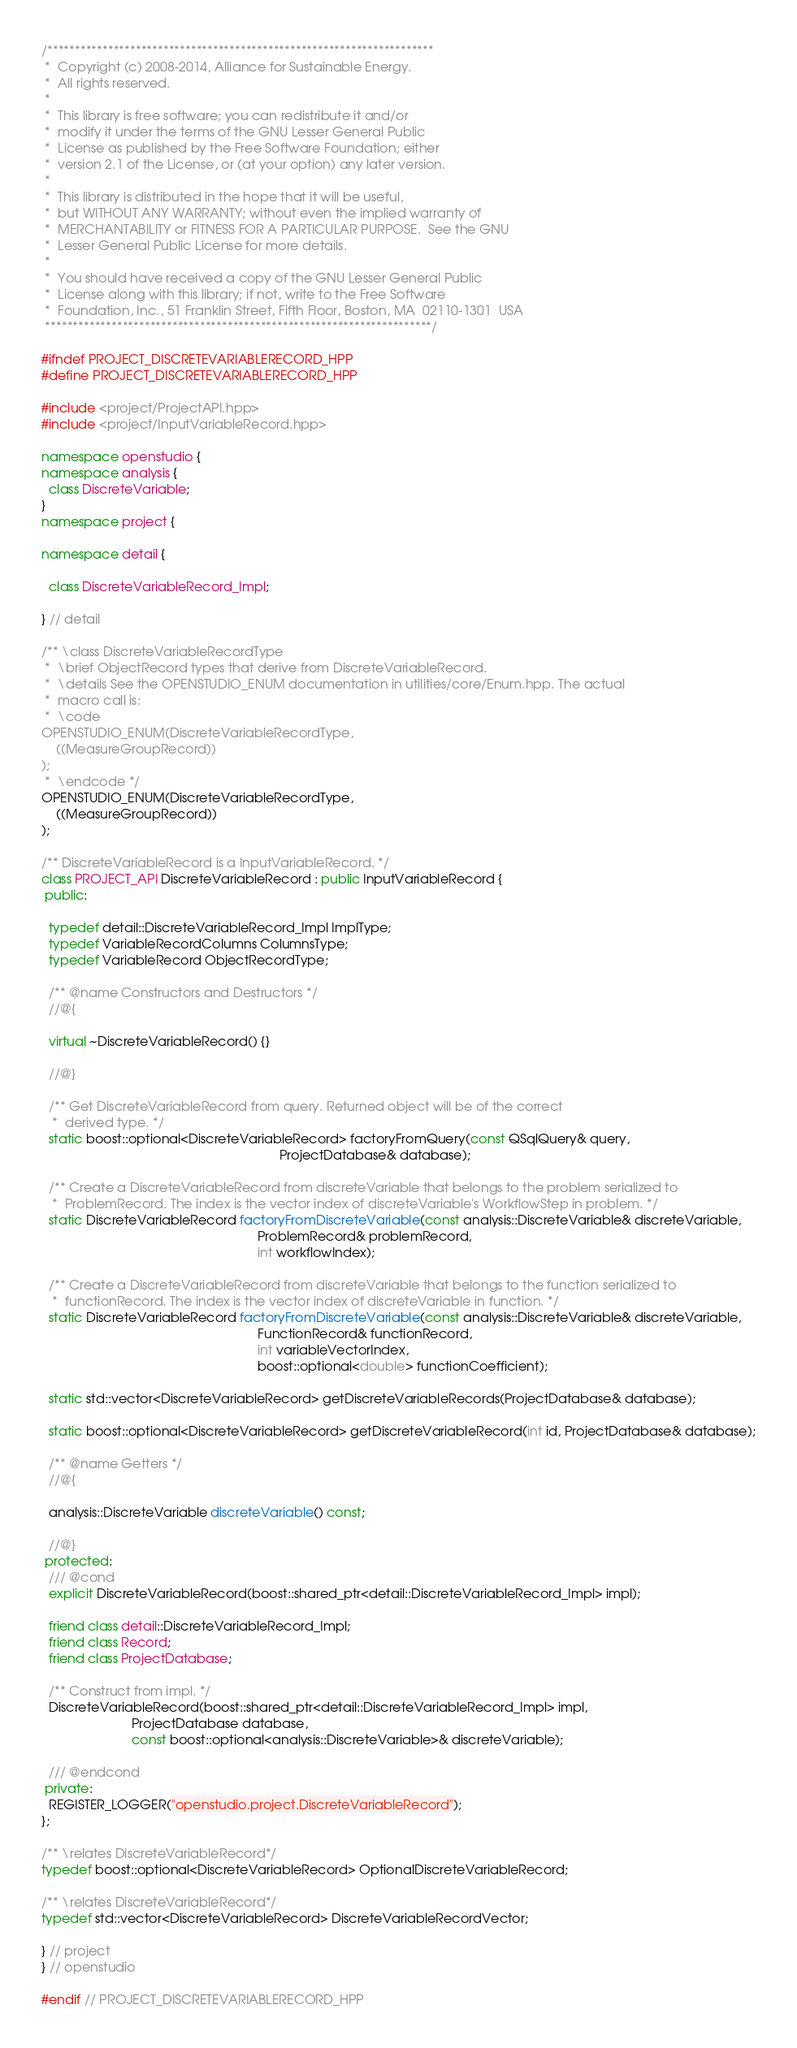Convert code to text. <code><loc_0><loc_0><loc_500><loc_500><_C++_>/**********************************************************************
 *  Copyright (c) 2008-2014, Alliance for Sustainable Energy.
 *  All rights reserved.
 *
 *  This library is free software; you can redistribute it and/or
 *  modify it under the terms of the GNU Lesser General Public
 *  License as published by the Free Software Foundation; either
 *  version 2.1 of the License, or (at your option) any later version.
 *
 *  This library is distributed in the hope that it will be useful,
 *  but WITHOUT ANY WARRANTY; without even the implied warranty of
 *  MERCHANTABILITY or FITNESS FOR A PARTICULAR PURPOSE.  See the GNU
 *  Lesser General Public License for more details.
 *
 *  You should have received a copy of the GNU Lesser General Public
 *  License along with this library; if not, write to the Free Software
 *  Foundation, Inc., 51 Franklin Street, Fifth Floor, Boston, MA  02110-1301  USA
 **********************************************************************/

#ifndef PROJECT_DISCRETEVARIABLERECORD_HPP
#define PROJECT_DISCRETEVARIABLERECORD_HPP

#include <project/ProjectAPI.hpp>
#include <project/InputVariableRecord.hpp>

namespace openstudio {
namespace analysis {
  class DiscreteVariable;
}
namespace project {

namespace detail {

  class DiscreteVariableRecord_Impl;

} // detail

/** \class DiscreteVariableRecordType
 *  \brief ObjectRecord types that derive from DiscreteVariableRecord.
 *  \details See the OPENSTUDIO_ENUM documentation in utilities/core/Enum.hpp. The actual
 *  macro call is:
 *  \code
OPENSTUDIO_ENUM(DiscreteVariableRecordType,
    ((MeasureGroupRecord))
);
 *  \endcode */
OPENSTUDIO_ENUM(DiscreteVariableRecordType,
    ((MeasureGroupRecord))
);

/** DiscreteVariableRecord is a InputVariableRecord. */
class PROJECT_API DiscreteVariableRecord : public InputVariableRecord {
 public:

  typedef detail::DiscreteVariableRecord_Impl ImplType;
  typedef VariableRecordColumns ColumnsType;
  typedef VariableRecord ObjectRecordType;

  /** @name Constructors and Destructors */
  //@{

  virtual ~DiscreteVariableRecord() {}

  //@}

  /** Get DiscreteVariableRecord from query. Returned object will be of the correct
   *  derived type. */
  static boost::optional<DiscreteVariableRecord> factoryFromQuery(const QSqlQuery& query,
                                                                  ProjectDatabase& database);

  /** Create a DiscreteVariableRecord from discreteVariable that belongs to the problem serialized to
   *  ProblemRecord. The index is the vector index of discreteVariable's WorkflowStep in problem. */
  static DiscreteVariableRecord factoryFromDiscreteVariable(const analysis::DiscreteVariable& discreteVariable,
                                                            ProblemRecord& problemRecord,
                                                            int workflowIndex);

  /** Create a DiscreteVariableRecord from discreteVariable that belongs to the function serialized to
   *  functionRecord. The index is the vector index of discreteVariable in function. */
  static DiscreteVariableRecord factoryFromDiscreteVariable(const analysis::DiscreteVariable& discreteVariable,
                                                            FunctionRecord& functionRecord,
                                                            int variableVectorIndex,
                                                            boost::optional<double> functionCoefficient);

  static std::vector<DiscreteVariableRecord> getDiscreteVariableRecords(ProjectDatabase& database);

  static boost::optional<DiscreteVariableRecord> getDiscreteVariableRecord(int id, ProjectDatabase& database);

  /** @name Getters */
  //@{

  analysis::DiscreteVariable discreteVariable() const;

  //@}
 protected:
  /// @cond
  explicit DiscreteVariableRecord(boost::shared_ptr<detail::DiscreteVariableRecord_Impl> impl);

  friend class detail::DiscreteVariableRecord_Impl;
  friend class Record;
  friend class ProjectDatabase;

  /** Construct from impl. */
  DiscreteVariableRecord(boost::shared_ptr<detail::DiscreteVariableRecord_Impl> impl,
                         ProjectDatabase database,
                         const boost::optional<analysis::DiscreteVariable>& discreteVariable);

  /// @endcond
 private:
  REGISTER_LOGGER("openstudio.project.DiscreteVariableRecord");
};

/** \relates DiscreteVariableRecord*/
typedef boost::optional<DiscreteVariableRecord> OptionalDiscreteVariableRecord;

/** \relates DiscreteVariableRecord*/
typedef std::vector<DiscreteVariableRecord> DiscreteVariableRecordVector;

} // project
} // openstudio

#endif // PROJECT_DISCRETEVARIABLERECORD_HPP

</code> 